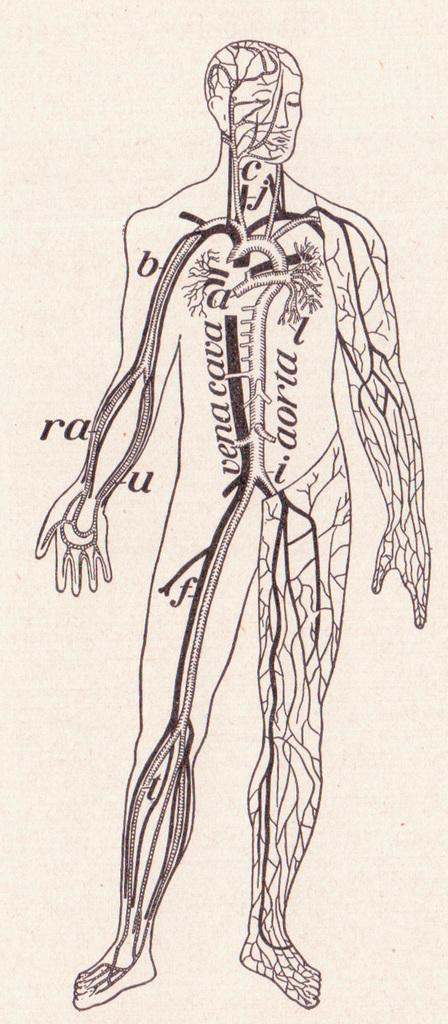What is the main subject in the foreground of the image? There is a diagram of a person in the foreground of the image. What other diagram can be seen in the foreground of the image? The diagram of internal parts of the body is present in the foreground of the image. How much payment is required to order the heat in the image? There is no payment, order, or heat present in the image; it only contains diagrams of a person and internal body parts. 